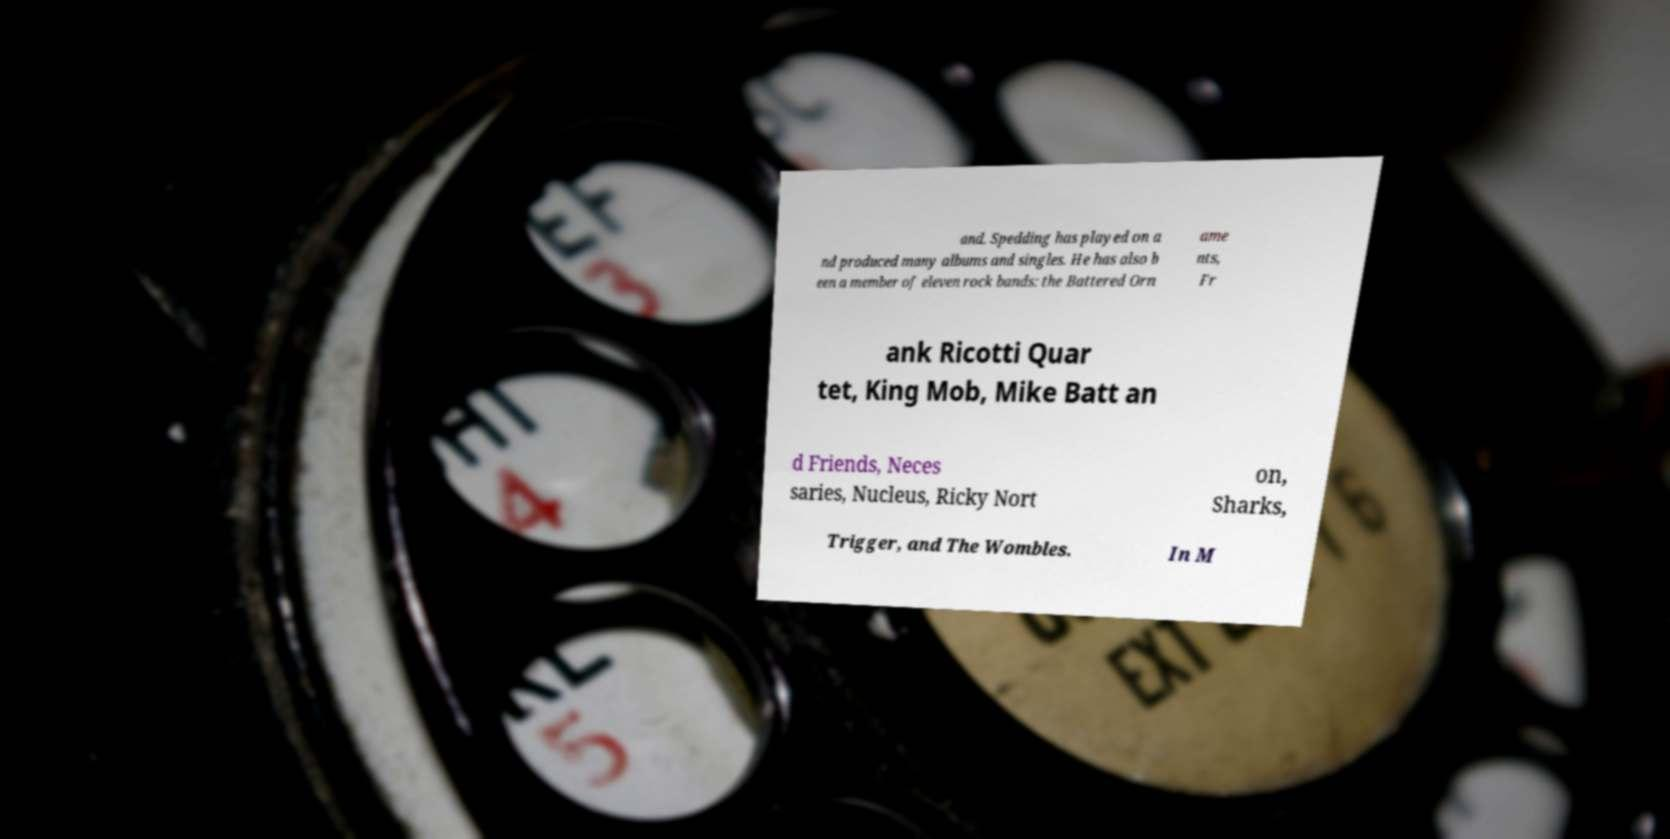What messages or text are displayed in this image? I need them in a readable, typed format. and. Spedding has played on a nd produced many albums and singles. He has also b een a member of eleven rock bands: the Battered Orn ame nts, Fr ank Ricotti Quar tet, King Mob, Mike Batt an d Friends, Neces saries, Nucleus, Ricky Nort on, Sharks, Trigger, and The Wombles. In M 